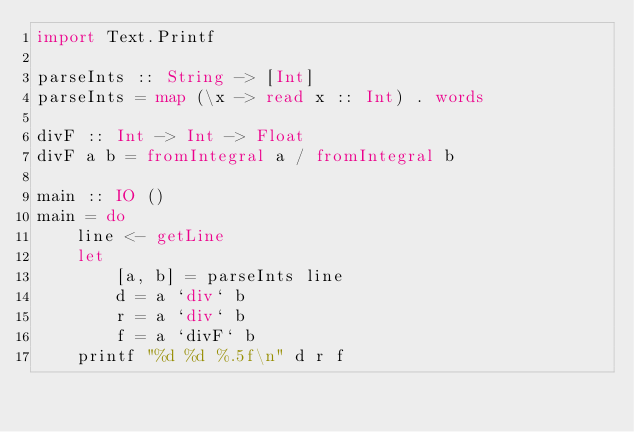Convert code to text. <code><loc_0><loc_0><loc_500><loc_500><_Haskell_>import Text.Printf

parseInts :: String -> [Int]
parseInts = map (\x -> read x :: Int) . words

divF :: Int -> Int -> Float
divF a b = fromIntegral a / fromIntegral b

main :: IO ()
main = do
    line <- getLine
    let
        [a, b] = parseInts line
        d = a `div` b
        r = a `div` b
        f = a `divF` b
    printf "%d %d %.5f\n" d r f</code> 